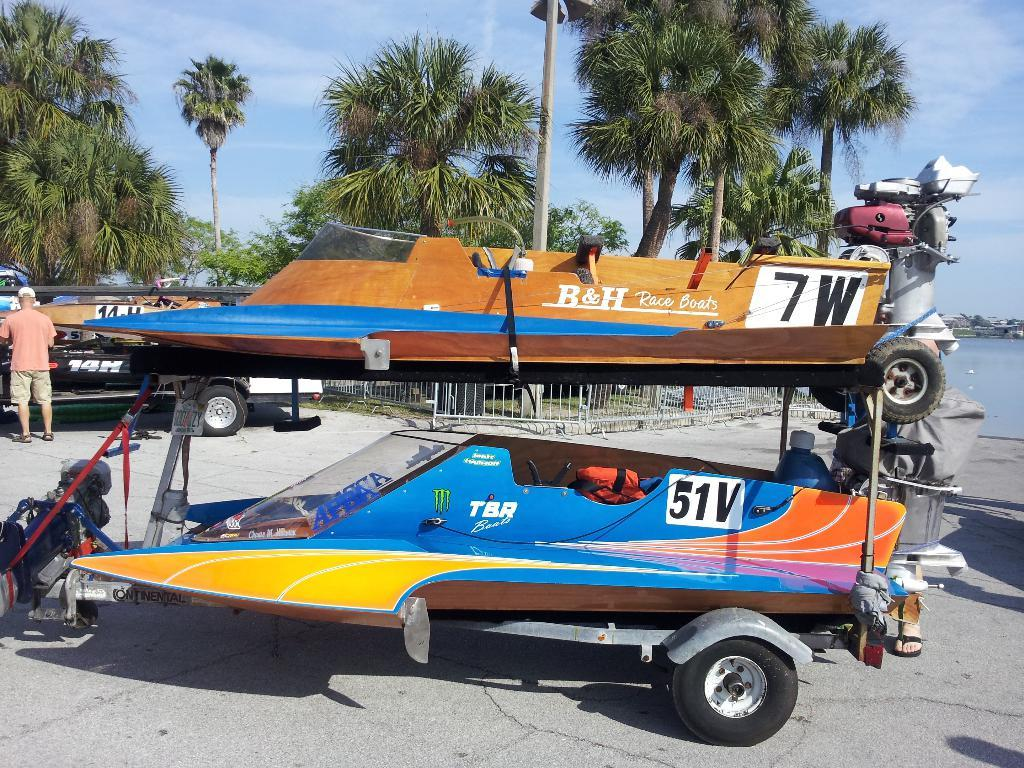<image>
Present a compact description of the photo's key features. A pair of ski boats on one trailer labeled 51v and 7w. 